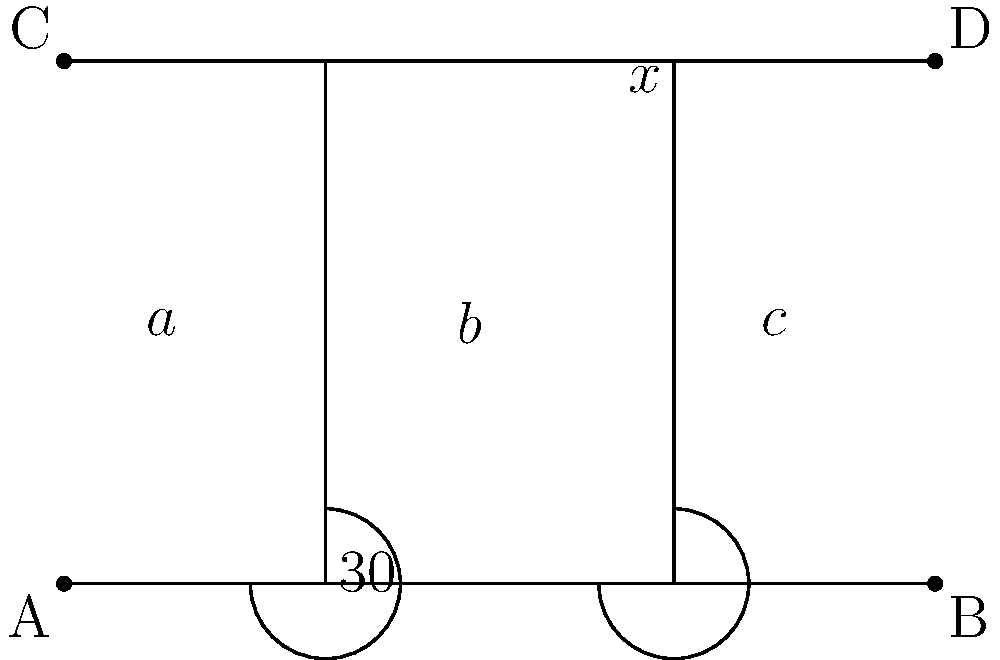In a simplified model of nerve fiber tracts in the brain, parallel lines represent bundles of axons, and transversals represent cross-connections. In the diagram, lines AB and CD are parallel, representing two main axon bundles. EF and GH are transversals, modeling cross-connections. If the angle formed by the first transversal EF with AB is 30°, and the three sections created by the transversals are labeled a, b, and c as shown, what is the value of x°? To solve this problem, we'll use the properties of parallel lines and transversals:

1. When parallel lines are cut by a transversal, corresponding angles are congruent.
2. The sum of the measures of the angles on the same side of a transversal is 180°.

Step 1: Identify that the angle labeled 30° and the angle labeled x° are alternate interior angles.

Step 2: Due to the property of alternate interior angles being congruent when parallel lines are cut by a transversal, we can conclude that:

$$x° = 30°$$

Step 3: To verify, we can check that the angles on the same side of the transversal GH sum to 180°:

$$x° + (180° - 30°) = 180°$$
$$30° + 150° = 180°$$

This confirms our result.

In the context of nerve fiber tracts, this property ensures that the cross-connections maintain consistent angular relationships with the main axon bundles, which is important for preserving the spatial organization and connectivity patterns in the brain.
Answer: $30°$ 